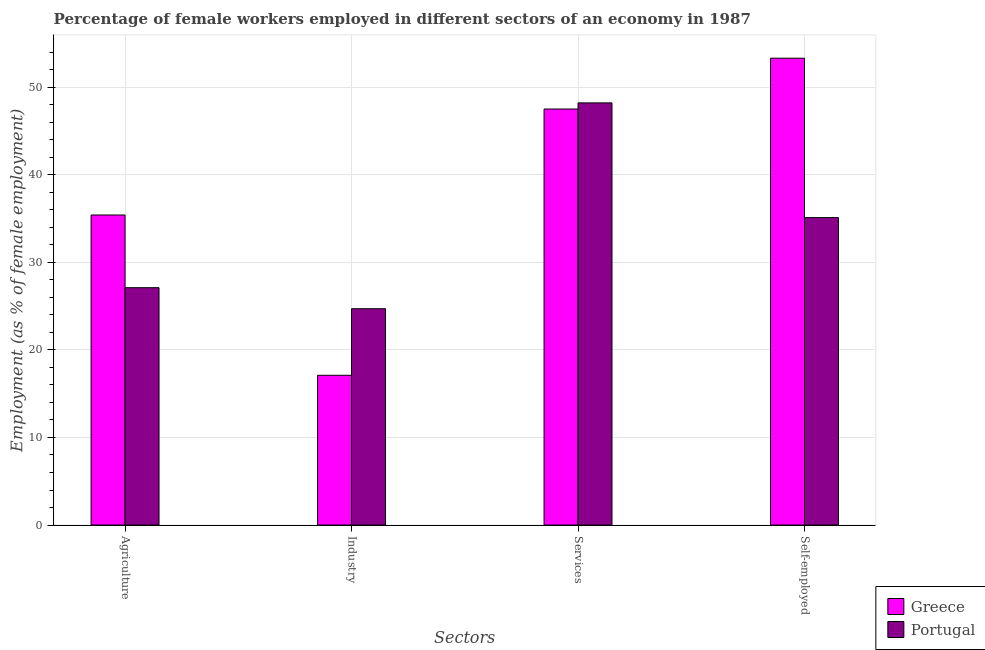Are the number of bars per tick equal to the number of legend labels?
Your response must be concise. Yes. Are the number of bars on each tick of the X-axis equal?
Your answer should be compact. Yes. What is the label of the 4th group of bars from the left?
Your response must be concise. Self-employed. What is the percentage of female workers in services in Greece?
Offer a terse response. 47.5. Across all countries, what is the maximum percentage of female workers in industry?
Provide a short and direct response. 24.7. Across all countries, what is the minimum percentage of female workers in industry?
Keep it short and to the point. 17.1. In which country was the percentage of female workers in industry minimum?
Offer a very short reply. Greece. What is the total percentage of self employed female workers in the graph?
Your response must be concise. 88.4. What is the difference between the percentage of female workers in services in Greece and that in Portugal?
Keep it short and to the point. -0.7. What is the difference between the percentage of female workers in services in Greece and the percentage of female workers in industry in Portugal?
Make the answer very short. 22.8. What is the average percentage of self employed female workers per country?
Ensure brevity in your answer.  44.2. What is the difference between the percentage of female workers in industry and percentage of female workers in services in Greece?
Make the answer very short. -30.4. What is the ratio of the percentage of self employed female workers in Greece to that in Portugal?
Provide a short and direct response. 1.52. What is the difference between the highest and the second highest percentage of self employed female workers?
Your response must be concise. 18.2. What is the difference between the highest and the lowest percentage of female workers in agriculture?
Give a very brief answer. 8.3. In how many countries, is the percentage of female workers in industry greater than the average percentage of female workers in industry taken over all countries?
Provide a short and direct response. 1. Is it the case that in every country, the sum of the percentage of female workers in agriculture and percentage of female workers in industry is greater than the percentage of female workers in services?
Keep it short and to the point. Yes. Are all the bars in the graph horizontal?
Provide a succinct answer. No. How many countries are there in the graph?
Make the answer very short. 2. Are the values on the major ticks of Y-axis written in scientific E-notation?
Offer a terse response. No. Does the graph contain any zero values?
Keep it short and to the point. No. Where does the legend appear in the graph?
Your response must be concise. Bottom right. How are the legend labels stacked?
Offer a terse response. Vertical. What is the title of the graph?
Your answer should be compact. Percentage of female workers employed in different sectors of an economy in 1987. What is the label or title of the X-axis?
Your answer should be very brief. Sectors. What is the label or title of the Y-axis?
Ensure brevity in your answer.  Employment (as % of female employment). What is the Employment (as % of female employment) in Greece in Agriculture?
Offer a very short reply. 35.4. What is the Employment (as % of female employment) in Portugal in Agriculture?
Your answer should be very brief. 27.1. What is the Employment (as % of female employment) of Greece in Industry?
Your answer should be very brief. 17.1. What is the Employment (as % of female employment) in Portugal in Industry?
Give a very brief answer. 24.7. What is the Employment (as % of female employment) of Greece in Services?
Your answer should be very brief. 47.5. What is the Employment (as % of female employment) of Portugal in Services?
Your answer should be compact. 48.2. What is the Employment (as % of female employment) of Greece in Self-employed?
Make the answer very short. 53.3. What is the Employment (as % of female employment) of Portugal in Self-employed?
Offer a very short reply. 35.1. Across all Sectors, what is the maximum Employment (as % of female employment) in Greece?
Make the answer very short. 53.3. Across all Sectors, what is the maximum Employment (as % of female employment) of Portugal?
Your response must be concise. 48.2. Across all Sectors, what is the minimum Employment (as % of female employment) of Greece?
Ensure brevity in your answer.  17.1. Across all Sectors, what is the minimum Employment (as % of female employment) in Portugal?
Your answer should be compact. 24.7. What is the total Employment (as % of female employment) of Greece in the graph?
Your answer should be very brief. 153.3. What is the total Employment (as % of female employment) in Portugal in the graph?
Your answer should be very brief. 135.1. What is the difference between the Employment (as % of female employment) in Greece in Agriculture and that in Industry?
Ensure brevity in your answer.  18.3. What is the difference between the Employment (as % of female employment) in Portugal in Agriculture and that in Services?
Offer a terse response. -21.1. What is the difference between the Employment (as % of female employment) in Greece in Agriculture and that in Self-employed?
Provide a short and direct response. -17.9. What is the difference between the Employment (as % of female employment) in Greece in Industry and that in Services?
Keep it short and to the point. -30.4. What is the difference between the Employment (as % of female employment) in Portugal in Industry and that in Services?
Provide a short and direct response. -23.5. What is the difference between the Employment (as % of female employment) of Greece in Industry and that in Self-employed?
Your answer should be compact. -36.2. What is the difference between the Employment (as % of female employment) of Greece in Services and that in Self-employed?
Your response must be concise. -5.8. What is the difference between the Employment (as % of female employment) in Greece in Agriculture and the Employment (as % of female employment) in Portugal in Industry?
Keep it short and to the point. 10.7. What is the difference between the Employment (as % of female employment) in Greece in Agriculture and the Employment (as % of female employment) in Portugal in Services?
Provide a short and direct response. -12.8. What is the difference between the Employment (as % of female employment) of Greece in Agriculture and the Employment (as % of female employment) of Portugal in Self-employed?
Provide a succinct answer. 0.3. What is the difference between the Employment (as % of female employment) of Greece in Industry and the Employment (as % of female employment) of Portugal in Services?
Keep it short and to the point. -31.1. What is the difference between the Employment (as % of female employment) in Greece in Industry and the Employment (as % of female employment) in Portugal in Self-employed?
Offer a terse response. -18. What is the average Employment (as % of female employment) in Greece per Sectors?
Provide a succinct answer. 38.33. What is the average Employment (as % of female employment) of Portugal per Sectors?
Provide a succinct answer. 33.77. What is the difference between the Employment (as % of female employment) in Greece and Employment (as % of female employment) in Portugal in Agriculture?
Ensure brevity in your answer.  8.3. What is the difference between the Employment (as % of female employment) of Greece and Employment (as % of female employment) of Portugal in Services?
Your answer should be compact. -0.7. What is the ratio of the Employment (as % of female employment) in Greece in Agriculture to that in Industry?
Provide a short and direct response. 2.07. What is the ratio of the Employment (as % of female employment) in Portugal in Agriculture to that in Industry?
Ensure brevity in your answer.  1.1. What is the ratio of the Employment (as % of female employment) in Greece in Agriculture to that in Services?
Provide a short and direct response. 0.75. What is the ratio of the Employment (as % of female employment) of Portugal in Agriculture to that in Services?
Your response must be concise. 0.56. What is the ratio of the Employment (as % of female employment) of Greece in Agriculture to that in Self-employed?
Your answer should be compact. 0.66. What is the ratio of the Employment (as % of female employment) of Portugal in Agriculture to that in Self-employed?
Provide a short and direct response. 0.77. What is the ratio of the Employment (as % of female employment) in Greece in Industry to that in Services?
Ensure brevity in your answer.  0.36. What is the ratio of the Employment (as % of female employment) of Portugal in Industry to that in Services?
Make the answer very short. 0.51. What is the ratio of the Employment (as % of female employment) of Greece in Industry to that in Self-employed?
Keep it short and to the point. 0.32. What is the ratio of the Employment (as % of female employment) in Portugal in Industry to that in Self-employed?
Your answer should be compact. 0.7. What is the ratio of the Employment (as % of female employment) in Greece in Services to that in Self-employed?
Provide a short and direct response. 0.89. What is the ratio of the Employment (as % of female employment) in Portugal in Services to that in Self-employed?
Ensure brevity in your answer.  1.37. What is the difference between the highest and the second highest Employment (as % of female employment) of Greece?
Provide a short and direct response. 5.8. What is the difference between the highest and the second highest Employment (as % of female employment) of Portugal?
Your answer should be very brief. 13.1. What is the difference between the highest and the lowest Employment (as % of female employment) in Greece?
Provide a succinct answer. 36.2. 